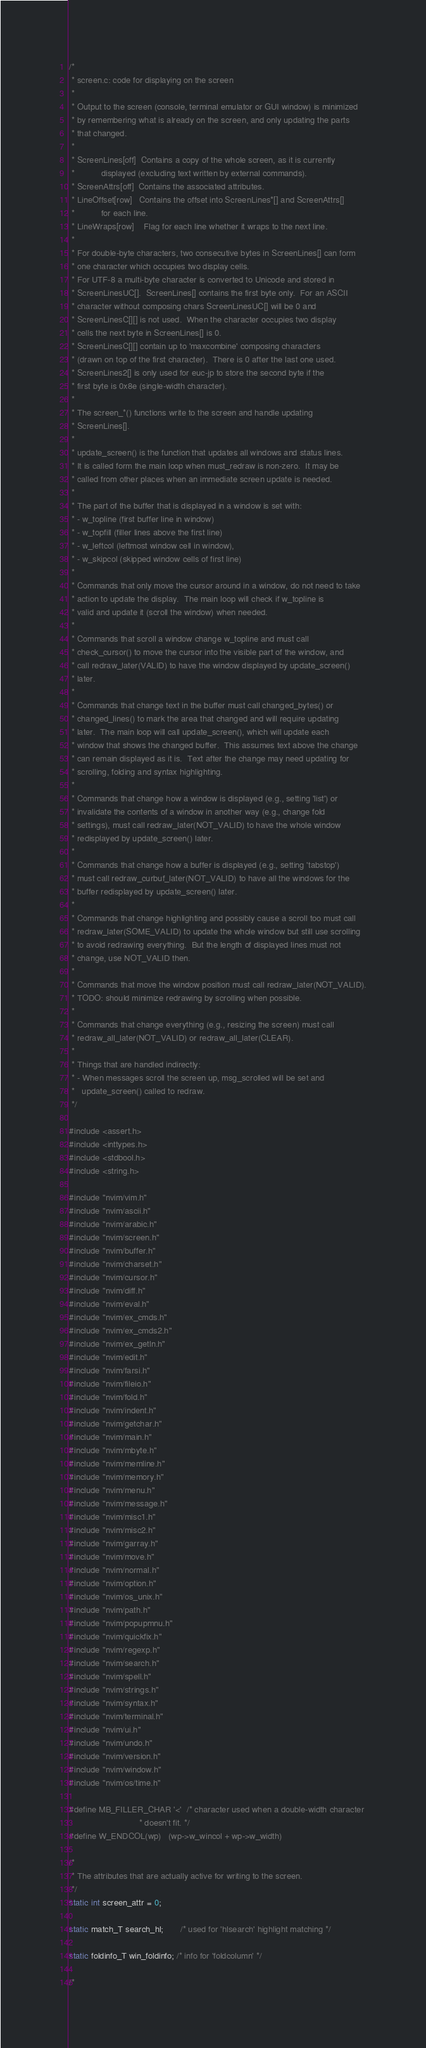Convert code to text. <code><loc_0><loc_0><loc_500><loc_500><_C_>/*
 * screen.c: code for displaying on the screen
 *
 * Output to the screen (console, terminal emulator or GUI window) is minimized
 * by remembering what is already on the screen, and only updating the parts
 * that changed.
 *
 * ScreenLines[off]  Contains a copy of the whole screen, as it is currently
 *		     displayed (excluding text written by external commands).
 * ScreenAttrs[off]  Contains the associated attributes.
 * LineOffset[row]   Contains the offset into ScreenLines*[] and ScreenAttrs[]
 *		     for each line.
 * LineWraps[row]    Flag for each line whether it wraps to the next line.
 *
 * For double-byte characters, two consecutive bytes in ScreenLines[] can form
 * one character which occupies two display cells.
 * For UTF-8 a multi-byte character is converted to Unicode and stored in
 * ScreenLinesUC[].  ScreenLines[] contains the first byte only.  For an ASCII
 * character without composing chars ScreenLinesUC[] will be 0 and
 * ScreenLinesC[][] is not used.  When the character occupies two display
 * cells the next byte in ScreenLines[] is 0.
 * ScreenLinesC[][] contain up to 'maxcombine' composing characters
 * (drawn on top of the first character).  There is 0 after the last one used.
 * ScreenLines2[] is only used for euc-jp to store the second byte if the
 * first byte is 0x8e (single-width character).
 *
 * The screen_*() functions write to the screen and handle updating
 * ScreenLines[].
 *
 * update_screen() is the function that updates all windows and status lines.
 * It is called form the main loop when must_redraw is non-zero.  It may be
 * called from other places when an immediate screen update is needed.
 *
 * The part of the buffer that is displayed in a window is set with:
 * - w_topline (first buffer line in window)
 * - w_topfill (filler lines above the first line)
 * - w_leftcol (leftmost window cell in window),
 * - w_skipcol (skipped window cells of first line)
 *
 * Commands that only move the cursor around in a window, do not need to take
 * action to update the display.  The main loop will check if w_topline is
 * valid and update it (scroll the window) when needed.
 *
 * Commands that scroll a window change w_topline and must call
 * check_cursor() to move the cursor into the visible part of the window, and
 * call redraw_later(VALID) to have the window displayed by update_screen()
 * later.
 *
 * Commands that change text in the buffer must call changed_bytes() or
 * changed_lines() to mark the area that changed and will require updating
 * later.  The main loop will call update_screen(), which will update each
 * window that shows the changed buffer.  This assumes text above the change
 * can remain displayed as it is.  Text after the change may need updating for
 * scrolling, folding and syntax highlighting.
 *
 * Commands that change how a window is displayed (e.g., setting 'list') or
 * invalidate the contents of a window in another way (e.g., change fold
 * settings), must call redraw_later(NOT_VALID) to have the whole window
 * redisplayed by update_screen() later.
 *
 * Commands that change how a buffer is displayed (e.g., setting 'tabstop')
 * must call redraw_curbuf_later(NOT_VALID) to have all the windows for the
 * buffer redisplayed by update_screen() later.
 *
 * Commands that change highlighting and possibly cause a scroll too must call
 * redraw_later(SOME_VALID) to update the whole window but still use scrolling
 * to avoid redrawing everything.  But the length of displayed lines must not
 * change, use NOT_VALID then.
 *
 * Commands that move the window position must call redraw_later(NOT_VALID).
 * TODO: should minimize redrawing by scrolling when possible.
 *
 * Commands that change everything (e.g., resizing the screen) must call
 * redraw_all_later(NOT_VALID) or redraw_all_later(CLEAR).
 *
 * Things that are handled indirectly:
 * - When messages scroll the screen up, msg_scrolled will be set and
 *   update_screen() called to redraw.
 */

#include <assert.h>
#include <inttypes.h>
#include <stdbool.h>
#include <string.h>

#include "nvim/vim.h"
#include "nvim/ascii.h"
#include "nvim/arabic.h"
#include "nvim/screen.h"
#include "nvim/buffer.h"
#include "nvim/charset.h"
#include "nvim/cursor.h"
#include "nvim/diff.h"
#include "nvim/eval.h"
#include "nvim/ex_cmds.h"
#include "nvim/ex_cmds2.h"
#include "nvim/ex_getln.h"
#include "nvim/edit.h"
#include "nvim/farsi.h"
#include "nvim/fileio.h"
#include "nvim/fold.h"
#include "nvim/indent.h"
#include "nvim/getchar.h"
#include "nvim/main.h"
#include "nvim/mbyte.h"
#include "nvim/memline.h"
#include "nvim/memory.h"
#include "nvim/menu.h"
#include "nvim/message.h"
#include "nvim/misc1.h"
#include "nvim/misc2.h"
#include "nvim/garray.h"
#include "nvim/move.h"
#include "nvim/normal.h"
#include "nvim/option.h"
#include "nvim/os_unix.h"
#include "nvim/path.h"
#include "nvim/popupmnu.h"
#include "nvim/quickfix.h"
#include "nvim/regexp.h"
#include "nvim/search.h"
#include "nvim/spell.h"
#include "nvim/strings.h"
#include "nvim/syntax.h"
#include "nvim/terminal.h"
#include "nvim/ui.h"
#include "nvim/undo.h"
#include "nvim/version.h"
#include "nvim/window.h"
#include "nvim/os/time.h"

#define MB_FILLER_CHAR '<'  /* character used when a double-width character
                             * doesn't fit. */
#define W_ENDCOL(wp)   (wp->w_wincol + wp->w_width)

/*
 * The attributes that are actually active for writing to the screen.
 */
static int screen_attr = 0;

static match_T search_hl;       /* used for 'hlsearch' highlight matching */

static foldinfo_T win_foldinfo; /* info for 'foldcolumn' */

/*</code> 